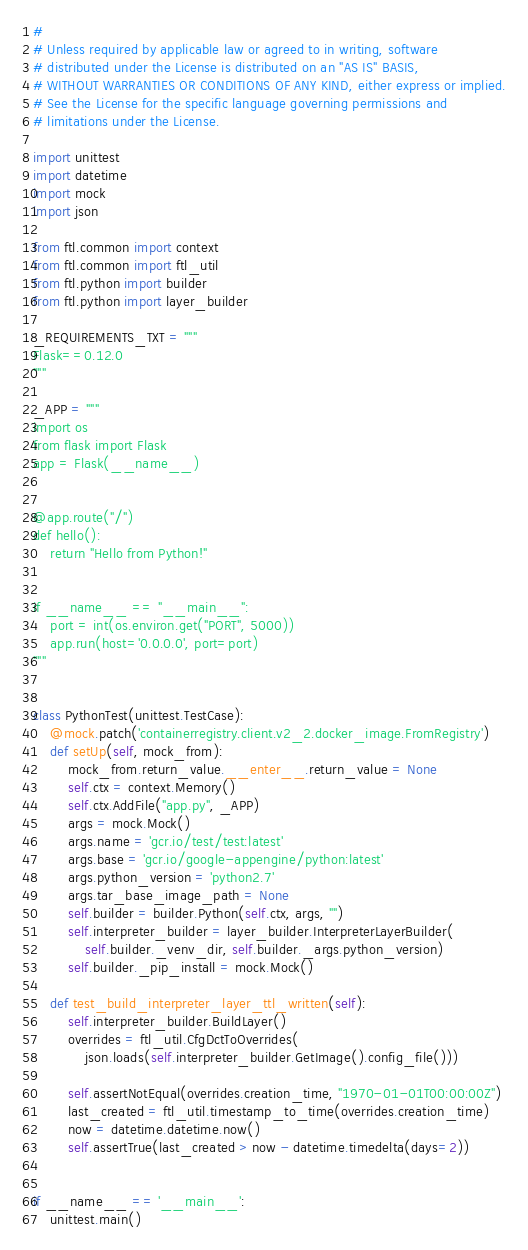Convert code to text. <code><loc_0><loc_0><loc_500><loc_500><_Python_>#
# Unless required by applicable law or agreed to in writing, software
# distributed under the License is distributed on an "AS IS" BASIS,
# WITHOUT WARRANTIES OR CONDITIONS OF ANY KIND, either express or implied.
# See the License for the specific language governing permissions and
# limitations under the License.

import unittest
import datetime
import mock
import json

from ftl.common import context
from ftl.common import ftl_util
from ftl.python import builder
from ftl.python import layer_builder

_REQUIREMENTS_TXT = """
Flask==0.12.0
"""

_APP = """
import os
from flask import Flask
app = Flask(__name__)


@app.route("/")
def hello():
    return "Hello from Python!"


if __name__ == "__main__":
    port = int(os.environ.get("PORT", 5000))
    app.run(host='0.0.0.0', port=port)
"""


class PythonTest(unittest.TestCase):
    @mock.patch('containerregistry.client.v2_2.docker_image.FromRegistry')
    def setUp(self, mock_from):
        mock_from.return_value.__enter__.return_value = None
        self.ctx = context.Memory()
        self.ctx.AddFile("app.py", _APP)
        args = mock.Mock()
        args.name = 'gcr.io/test/test:latest'
        args.base = 'gcr.io/google-appengine/python:latest'
        args.python_version = 'python2.7'
        args.tar_base_image_path = None
        self.builder = builder.Python(self.ctx, args, "")
        self.interpreter_builder = layer_builder.InterpreterLayerBuilder(
            self.builder._venv_dir, self.builder._args.python_version)
        self.builder._pip_install = mock.Mock()

    def test_build_interpreter_layer_ttl_written(self):
        self.interpreter_builder.BuildLayer()
        overrides = ftl_util.CfgDctToOverrides(
            json.loads(self.interpreter_builder.GetImage().config_file()))

        self.assertNotEqual(overrides.creation_time, "1970-01-01T00:00:00Z")
        last_created = ftl_util.timestamp_to_time(overrides.creation_time)
        now = datetime.datetime.now()
        self.assertTrue(last_created > now - datetime.timedelta(days=2))


if __name__ == '__main__':
    unittest.main()
</code> 